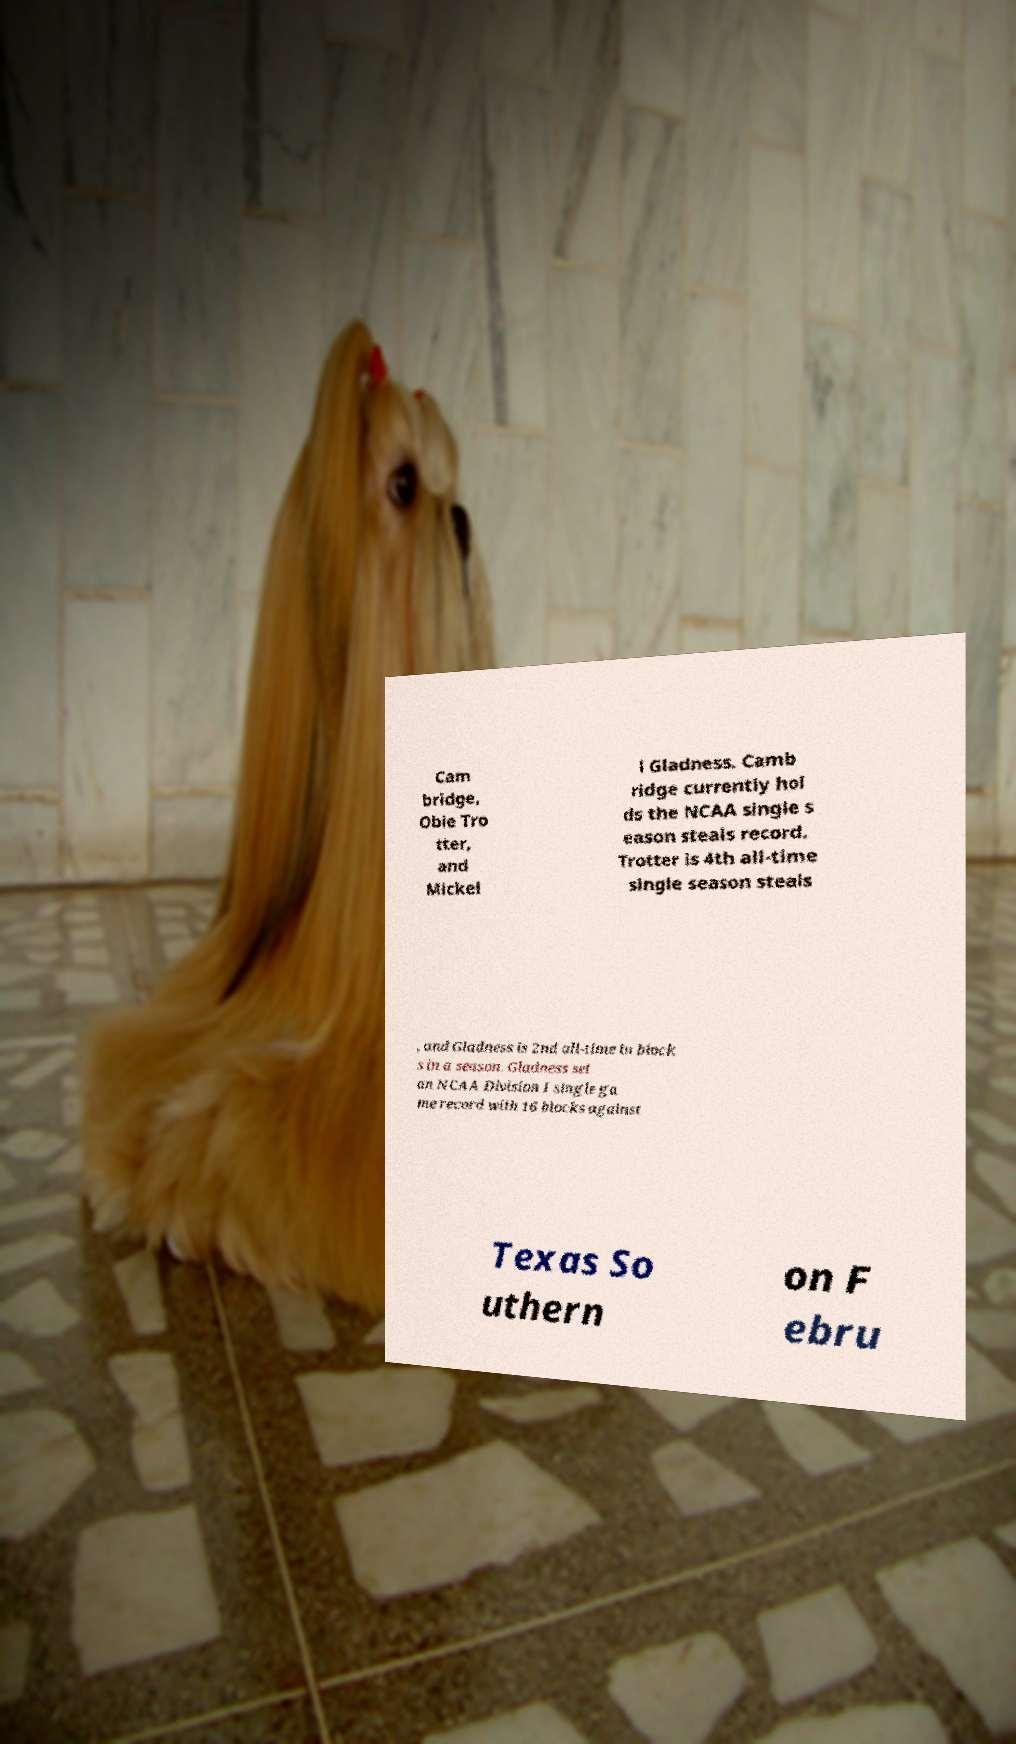I need the written content from this picture converted into text. Can you do that? Cam bridge, Obie Tro tter, and Mickel l Gladness. Camb ridge currently hol ds the NCAA single s eason steals record. Trotter is 4th all-time single season steals , and Gladness is 2nd all-time in block s in a season. Gladness set an NCAA Division I single ga me record with 16 blocks against Texas So uthern on F ebru 